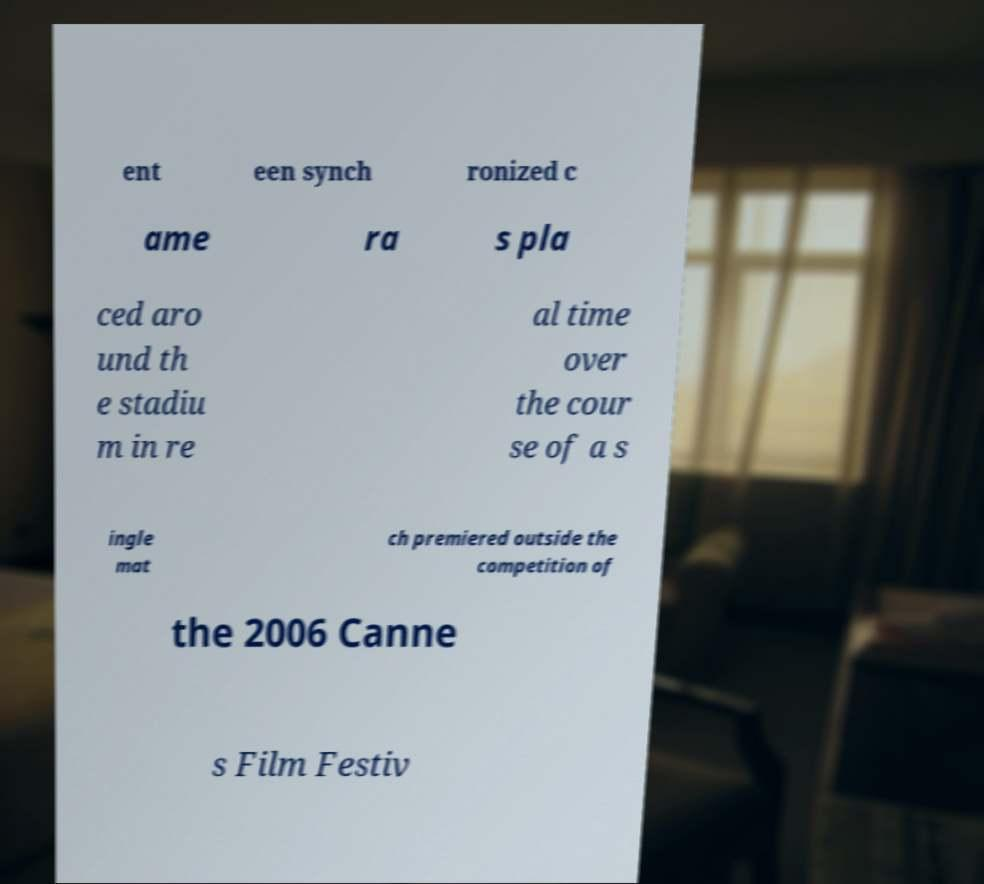Please identify and transcribe the text found in this image. ent een synch ronized c ame ra s pla ced aro und th e stadiu m in re al time over the cour se of a s ingle mat ch premiered outside the competition of the 2006 Canne s Film Festiv 